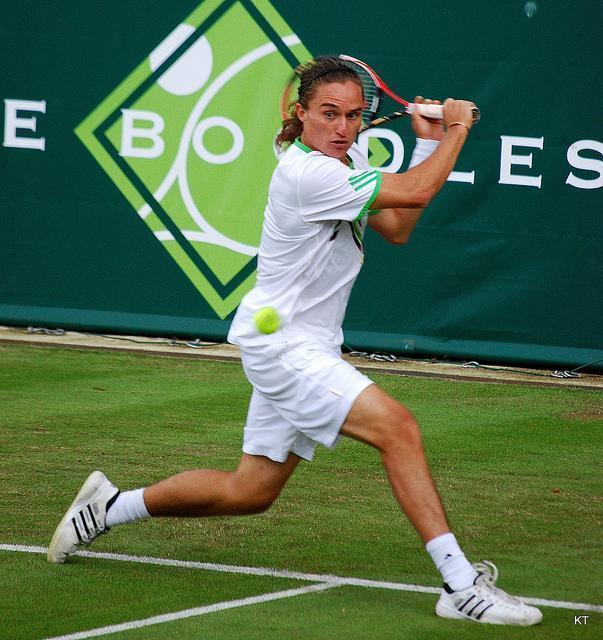How many vases have flowers in them?
Give a very brief answer. 0. 